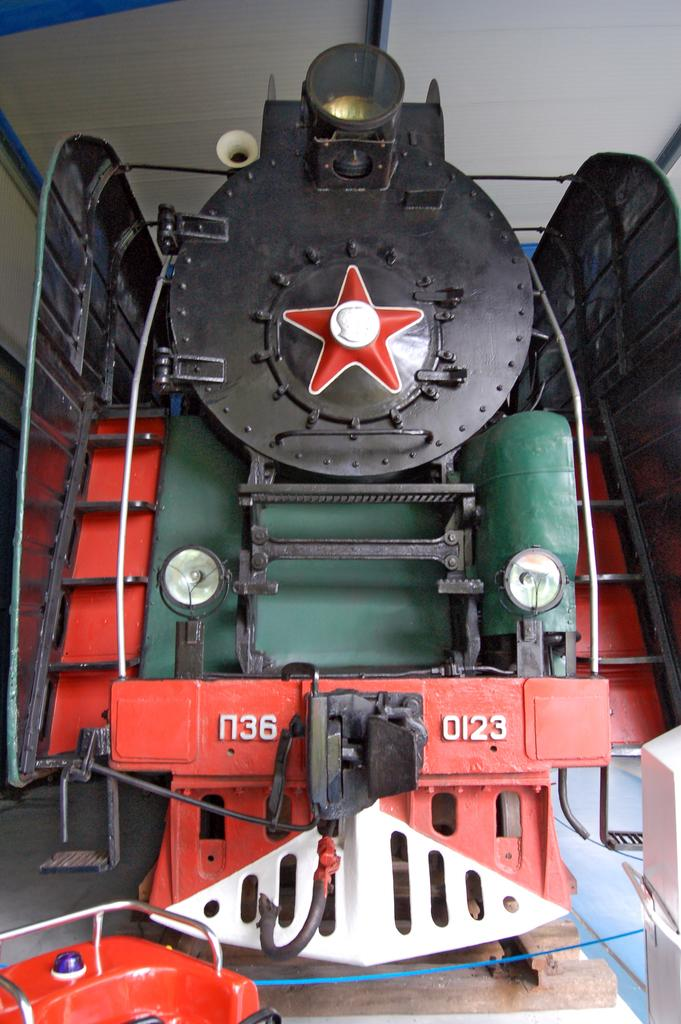What is the main subject of the image? The main subject of the image is a train engine. How is the train engine positioned in the image? The train engine is placed on the ground. What can be seen in the background of the image? There is a shed in the background of the image. How many eyes can be seen on the train engine in the image? There are no eyes visible on the train engine in the image, as it is a machine and not a living being. 